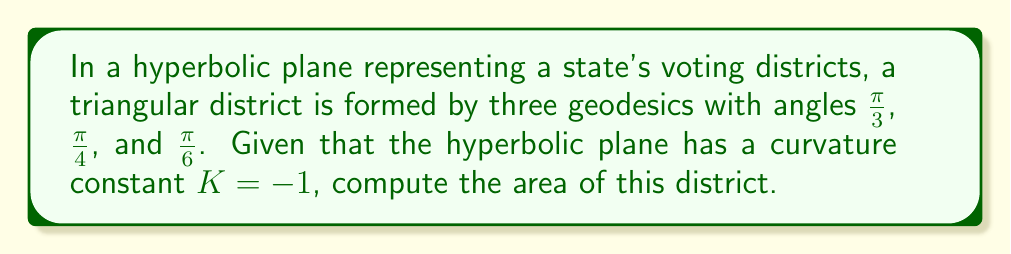Provide a solution to this math problem. To solve this problem, we'll use the Gauss-Bonnet formula for hyperbolic geometry:

1) The Gauss-Bonnet formula for a hyperbolic triangle states:
   $$A = \pi - (\alpha + \beta + \gamma)$$
   where $A$ is the area and $\alpha$, $\beta$, and $\gamma$ are the angles of the triangle.

2) We're given the angles:
   $\alpha = \frac{\pi}{3}$, $\beta = \frac{\pi}{4}$, and $\gamma = \frac{\pi}{6}$

3) Substituting these into the formula:
   $$A = \pi - (\frac{\pi}{3} + \frac{\pi}{4} + \frac{\pi}{6})$$

4) Simplifying:
   $$A = \pi - (\frac{4\pi}{12} + \frac{3\pi}{12} + \frac{2\pi}{12})$$
   $$A = \pi - \frac{9\pi}{12}$$
   $$A = \frac{12\pi}{12} - \frac{9\pi}{12}$$
   $$A = \frac{3\pi}{12}$$
   $$A = \frac{\pi}{4}$$

5) Since the curvature constant $K = -1$, the actual area is the negative of this value:
   $$\text{Actual Area} = -\frac{\pi}{4}$$

This negative area is a characteristic of hyperbolic geometry and represents the excess area compared to a Euclidean triangle with the same angles.
Answer: $-\frac{\pi}{4}$ 